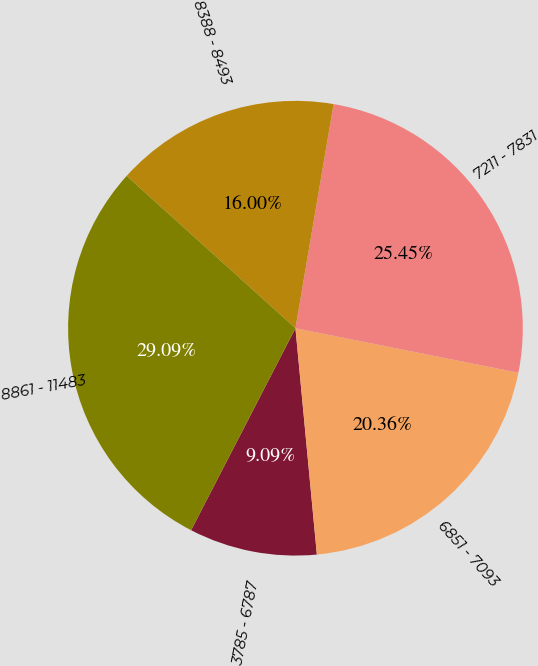Convert chart to OTSL. <chart><loc_0><loc_0><loc_500><loc_500><pie_chart><fcel>3785 - 6787<fcel>6851 - 7093<fcel>7211 - 7831<fcel>8388 - 8493<fcel>8861 - 11483<nl><fcel>9.09%<fcel>20.36%<fcel>25.45%<fcel>16.0%<fcel>29.09%<nl></chart> 